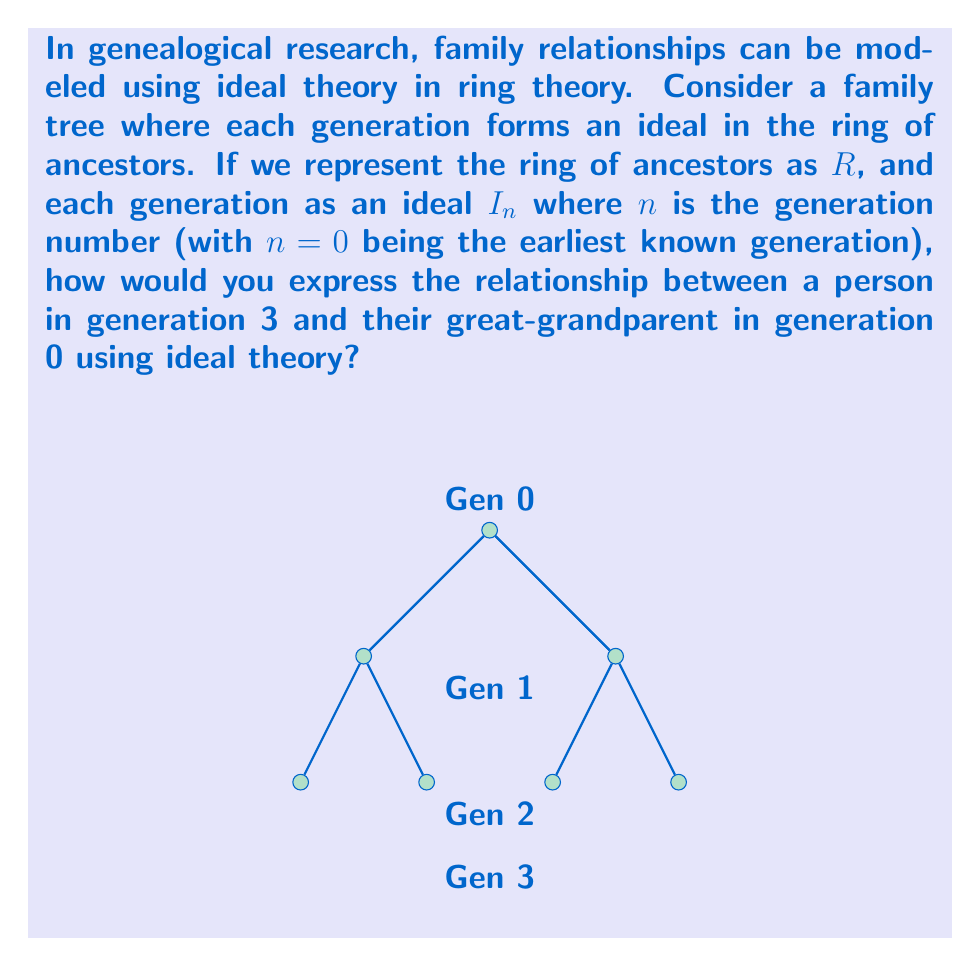What is the answer to this math problem? Let's approach this step-by-step:

1) In ideal theory, if $I$ and $J$ are ideals of a ring $R$, then their product $IJ$ is defined as the set of all finite sums of products of elements from $I$ and $J$.

2) In our genealogical model:
   - $R$ represents the ring of all ancestors
   - $I_0$ represents the earliest known generation (great-grandparents)
   - $I_1$ represents the grandparents' generation
   - $I_2$ represents the parents' generation
   - $I_3$ represents the current generation

3) The relationship between generations can be expressed as products of ideals:
   - $I_1 = I_0I_1$ (grandparents are descendants of great-grandparents)
   - $I_2 = I_0I_1I_2$ (parents are descendants of great-grandparents and grandparents)
   - $I_3 = I_0I_1I_2I_3$ (current generation is descendant of all previous generations)

4) To express the relationship between a person in generation 3 and their great-grandparent in generation 0, we need to show that $I_3 \subseteq I_0$.

5) We can prove this using the properties of ideals:
   $I_3 = I_0I_1I_2I_3 \subseteq I_0(R)R = I_0R = I_0$

6) This inclusion $I_3 \subseteq I_0$ represents the fact that genetic material and family traits from the great-grandparents (gen 0) are present in the current generation (gen 3).

Therefore, the relationship between a person in generation 3 and their great-grandparent in generation 0 can be expressed as $I_3 \subseteq I_0$ in ideal theory.
Answer: $I_3 \subseteq I_0$ 